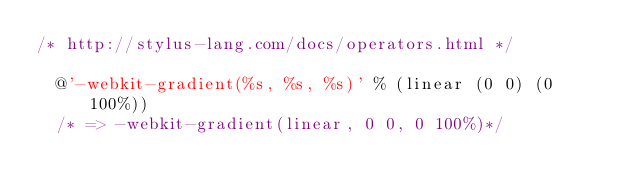<code> <loc_0><loc_0><loc_500><loc_500><_CSS_>/* http://stylus-lang.com/docs/operators.html */

  @'-webkit-gradient(%s, %s, %s)' % (linear (0 0) (0 100%))
  /* => -webkit-gradient(linear, 0 0, 0 100%)*/</code> 